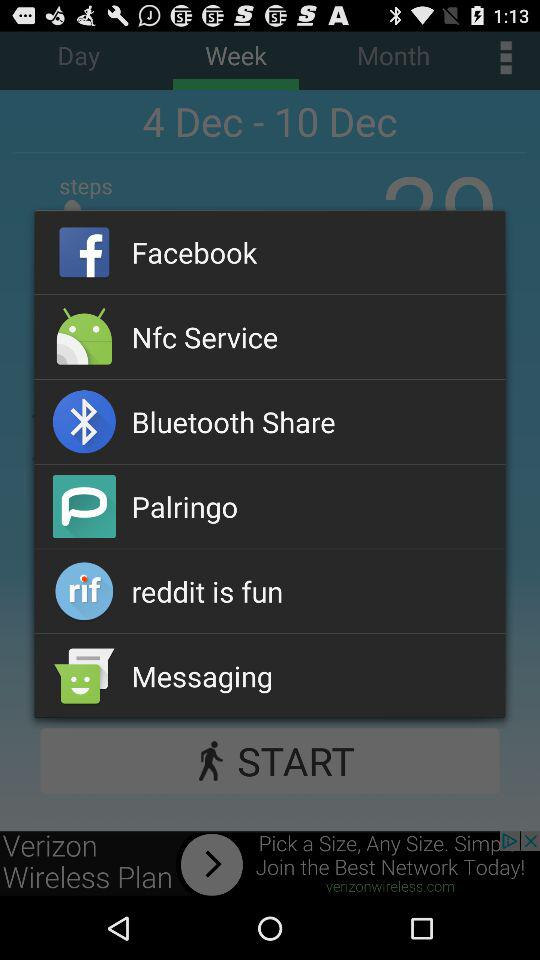What is the workout week date range? The workout week date range is from December 4 to December 10. 